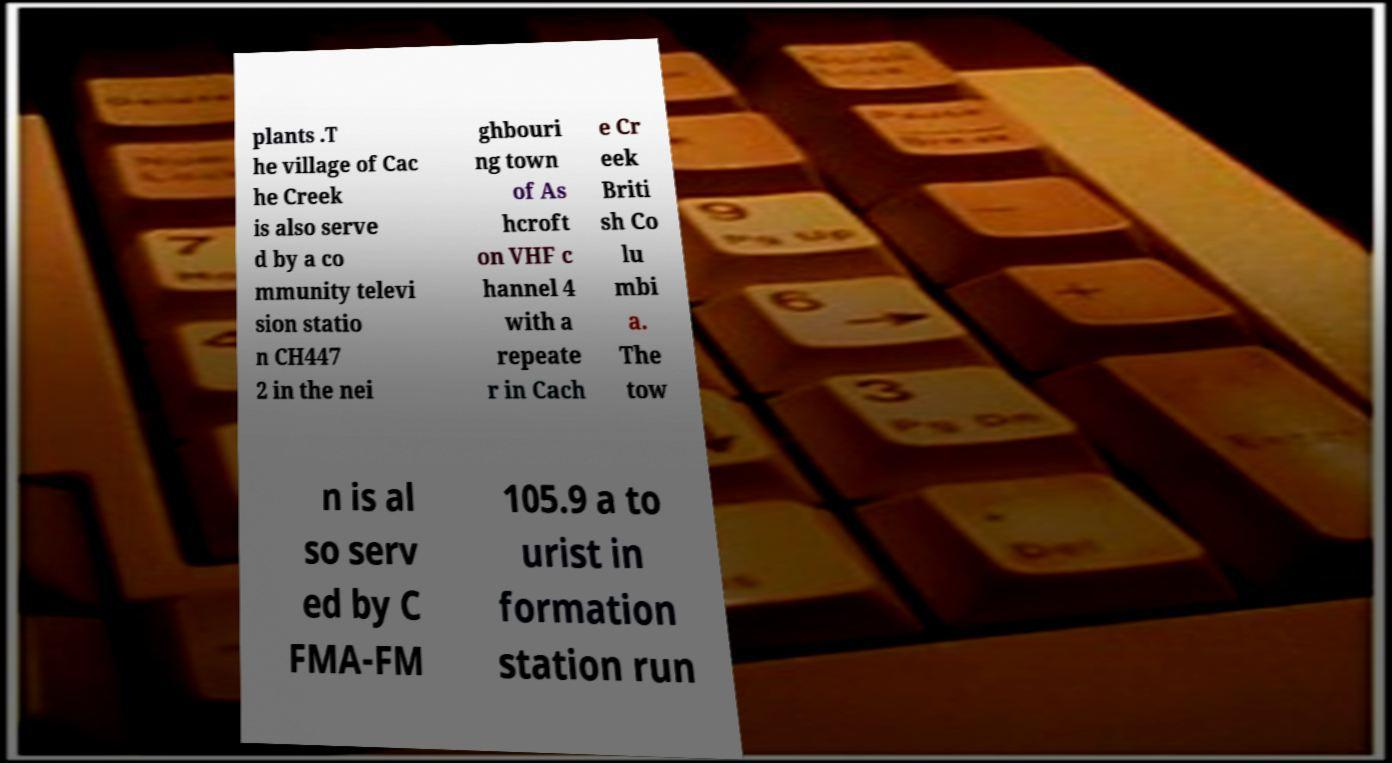What messages or text are displayed in this image? I need them in a readable, typed format. plants .T he village of Cac he Creek is also serve d by a co mmunity televi sion statio n CH447 2 in the nei ghbouri ng town of As hcroft on VHF c hannel 4 with a repeate r in Cach e Cr eek Briti sh Co lu mbi a. The tow n is al so serv ed by C FMA-FM 105.9 a to urist in formation station run 